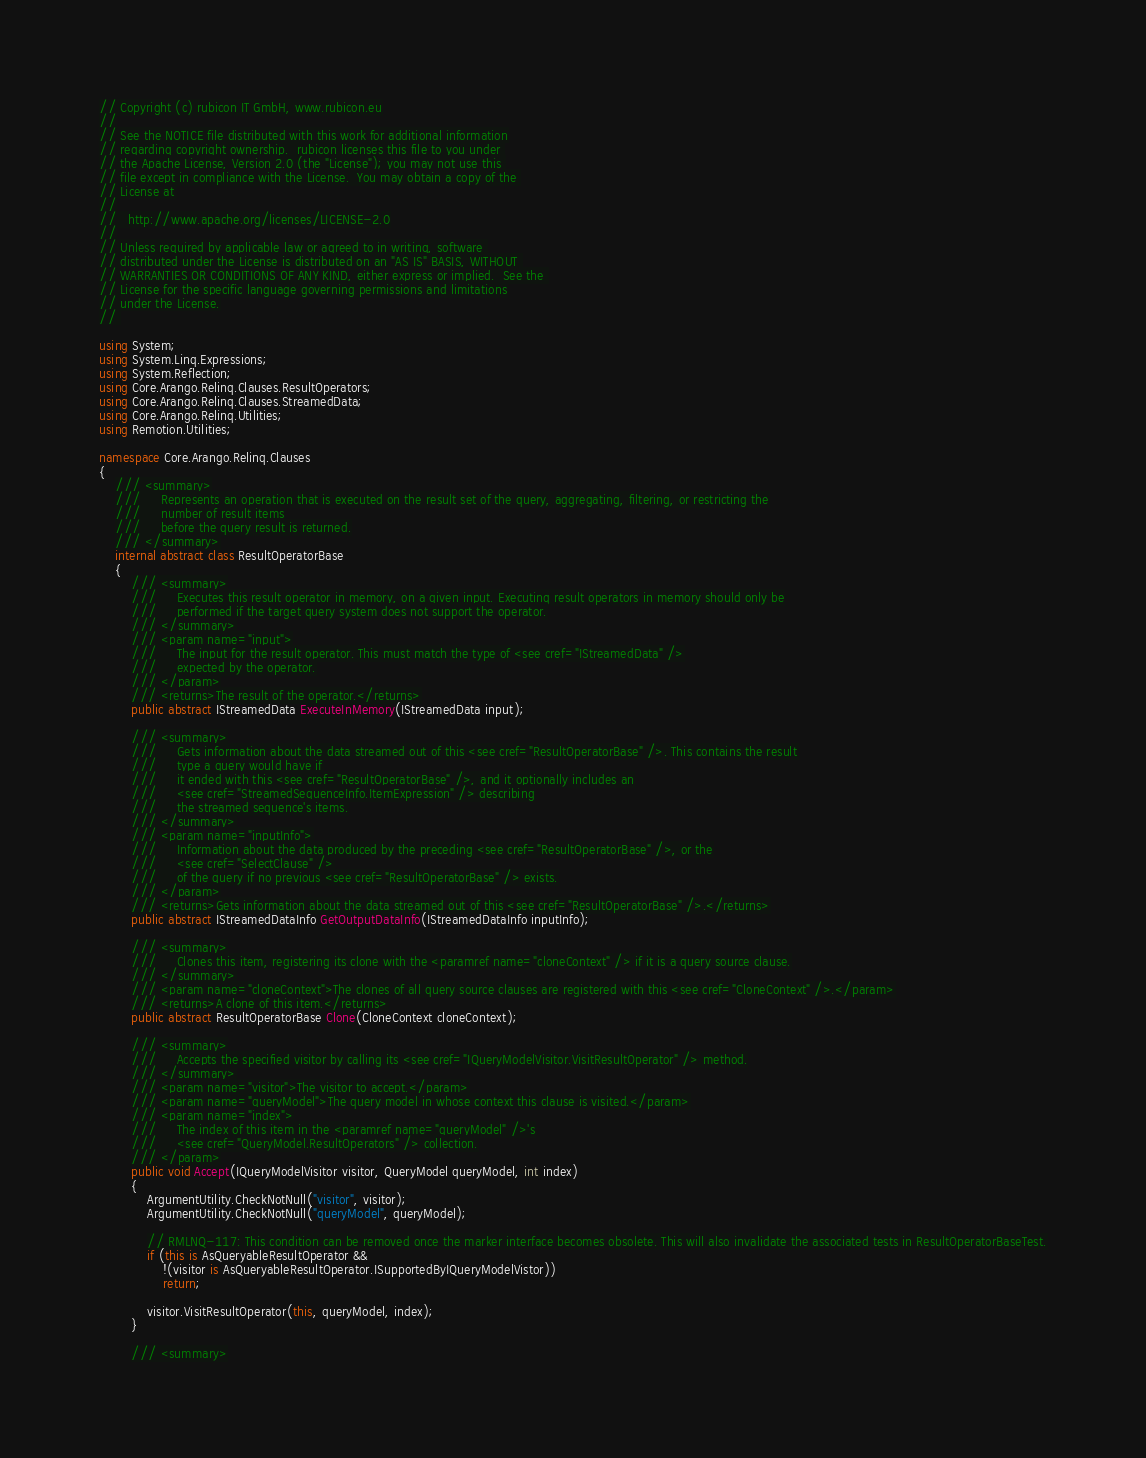Convert code to text. <code><loc_0><loc_0><loc_500><loc_500><_C#_>// Copyright (c) rubicon IT GmbH, www.rubicon.eu
//
// See the NOTICE file distributed with this work for additional information
// regarding copyright ownership.  rubicon licenses this file to you under 
// the Apache License, Version 2.0 (the "License"); you may not use this 
// file except in compliance with the License.  You may obtain a copy of the 
// License at
//
//   http://www.apache.org/licenses/LICENSE-2.0
//
// Unless required by applicable law or agreed to in writing, software 
// distributed under the License is distributed on an "AS IS" BASIS, WITHOUT 
// WARRANTIES OR CONDITIONS OF ANY KIND, either express or implied.  See the 
// License for the specific language governing permissions and limitations
// under the License.
// 

using System;
using System.Linq.Expressions;
using System.Reflection;
using Core.Arango.Relinq.Clauses.ResultOperators;
using Core.Arango.Relinq.Clauses.StreamedData;
using Core.Arango.Relinq.Utilities;
using Remotion.Utilities;

namespace Core.Arango.Relinq.Clauses
{
    /// <summary>
    ///     Represents an operation that is executed on the result set of the query, aggregating, filtering, or restricting the
    ///     number of result items
    ///     before the query result is returned.
    /// </summary>
    internal abstract class ResultOperatorBase
    {
        /// <summary>
        ///     Executes this result operator in memory, on a given input. Executing result operators in memory should only be
        ///     performed if the target query system does not support the operator.
        /// </summary>
        /// <param name="input">
        ///     The input for the result operator. This must match the type of <see cref="IStreamedData" />
        ///     expected by the operator.
        /// </param>
        /// <returns>The result of the operator.</returns>
        public abstract IStreamedData ExecuteInMemory(IStreamedData input);

        /// <summary>
        ///     Gets information about the data streamed out of this <see cref="ResultOperatorBase" />. This contains the result
        ///     type a query would have if
        ///     it ended with this <see cref="ResultOperatorBase" />, and it optionally includes an
        ///     <see cref="StreamedSequenceInfo.ItemExpression" /> describing
        ///     the streamed sequence's items.
        /// </summary>
        /// <param name="inputInfo">
        ///     Information about the data produced by the preceding <see cref="ResultOperatorBase" />, or the
        ///     <see cref="SelectClause" />
        ///     of the query if no previous <see cref="ResultOperatorBase" /> exists.
        /// </param>
        /// <returns>Gets information about the data streamed out of this <see cref="ResultOperatorBase" />.</returns>
        public abstract IStreamedDataInfo GetOutputDataInfo(IStreamedDataInfo inputInfo);

        /// <summary>
        ///     Clones this item, registering its clone with the <paramref name="cloneContext" /> if it is a query source clause.
        /// </summary>
        /// <param name="cloneContext">The clones of all query source clauses are registered with this <see cref="CloneContext" />.</param>
        /// <returns>A clone of this item.</returns>
        public abstract ResultOperatorBase Clone(CloneContext cloneContext);

        /// <summary>
        ///     Accepts the specified visitor by calling its <see cref="IQueryModelVisitor.VisitResultOperator" /> method.
        /// </summary>
        /// <param name="visitor">The visitor to accept.</param>
        /// <param name="queryModel">The query model in whose context this clause is visited.</param>
        /// <param name="index">
        ///     The index of this item in the <paramref name="queryModel" />'s
        ///     <see cref="QueryModel.ResultOperators" /> collection.
        /// </param>
        public void Accept(IQueryModelVisitor visitor, QueryModel queryModel, int index)
        {
            ArgumentUtility.CheckNotNull("visitor", visitor);
            ArgumentUtility.CheckNotNull("queryModel", queryModel);

            // RMLNQ-117: This condition can be removed once the marker interface becomes obsolete. This will also invalidate the associated tests in ResultOperatorBaseTest.
            if (this is AsQueryableResultOperator &&
                !(visitor is AsQueryableResultOperator.ISupportedByIQueryModelVistor))
                return;

            visitor.VisitResultOperator(this, queryModel, index);
        }

        /// <summary></code> 